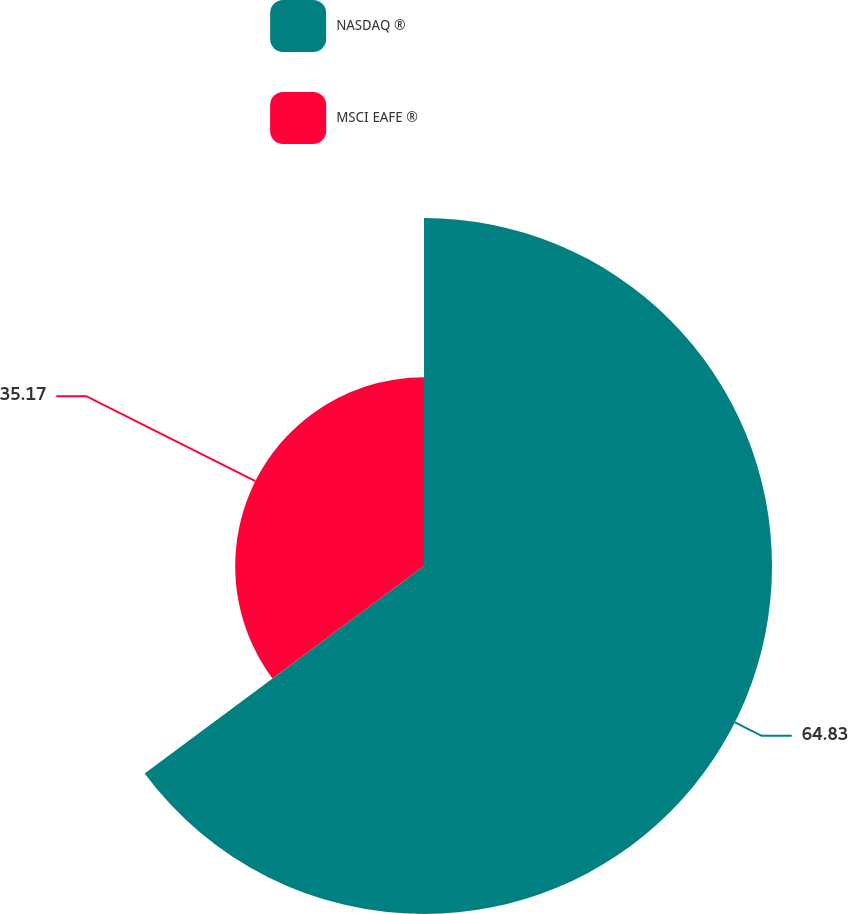Convert chart. <chart><loc_0><loc_0><loc_500><loc_500><pie_chart><fcel>NASDAQ ®<fcel>MSCI EAFE ®<nl><fcel>64.83%<fcel>35.17%<nl></chart> 